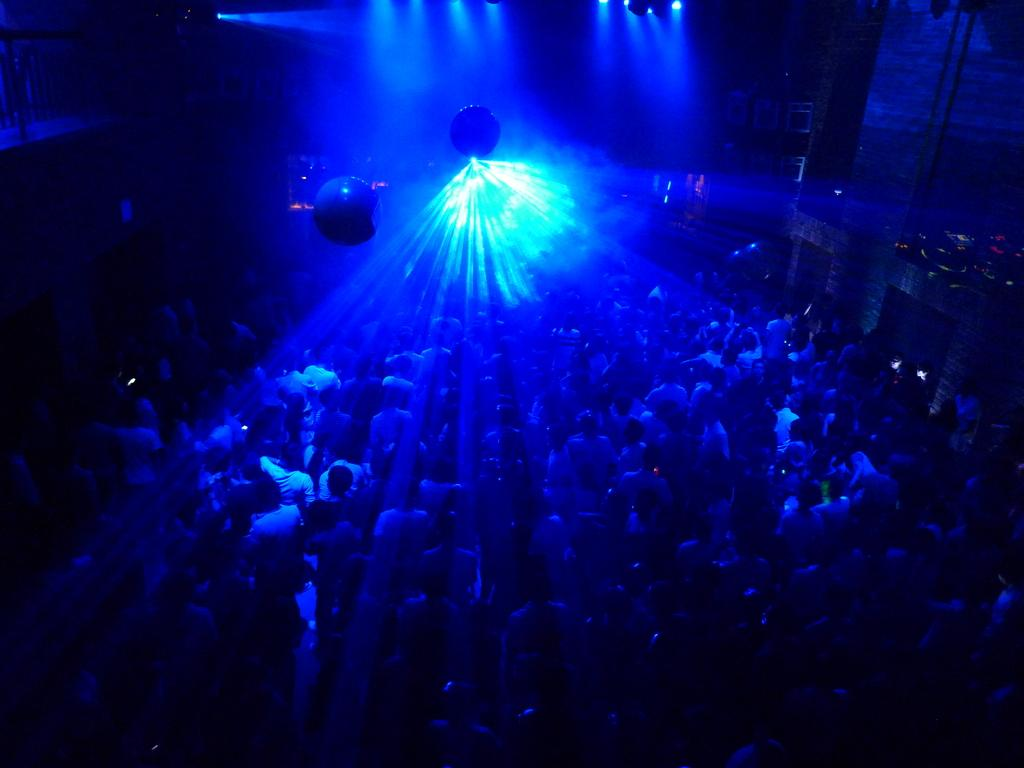Who or what is present in the image? There are people in the image. Can you describe the lighting in the image? There is light in the middle and top of the image, and it is in blue color. Where is the zebra located in the image? A: There is no zebra present in the image. What type of ornament is hanging from the ceiling in the image? There is no ornament mentioned or visible in the image. 